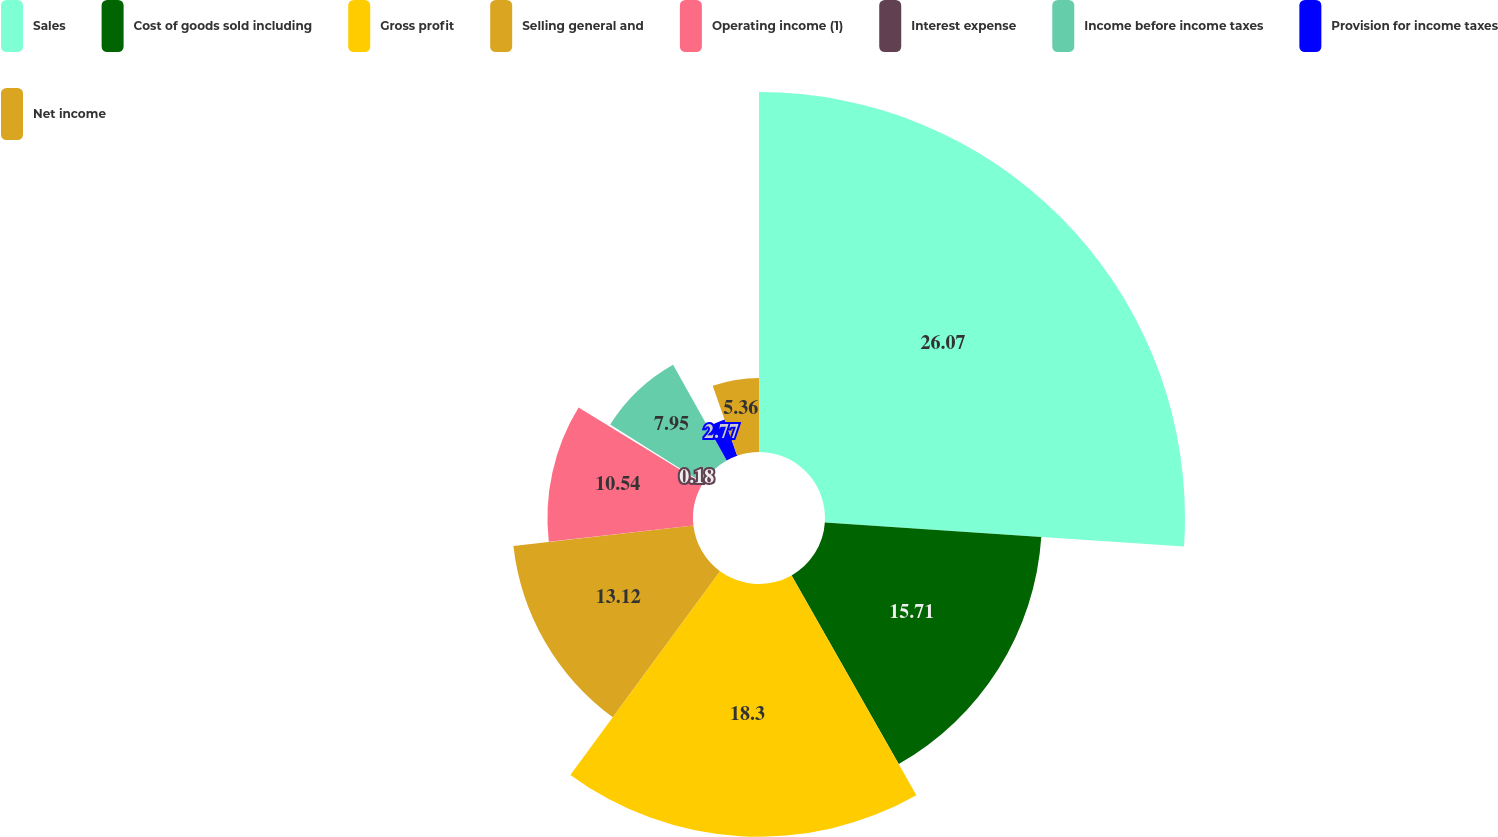Convert chart. <chart><loc_0><loc_0><loc_500><loc_500><pie_chart><fcel>Sales<fcel>Cost of goods sold including<fcel>Gross profit<fcel>Selling general and<fcel>Operating income (1)<fcel>Interest expense<fcel>Income before income taxes<fcel>Provision for income taxes<fcel>Net income<nl><fcel>26.07%<fcel>15.71%<fcel>18.3%<fcel>13.12%<fcel>10.54%<fcel>0.18%<fcel>7.95%<fcel>2.77%<fcel>5.36%<nl></chart> 